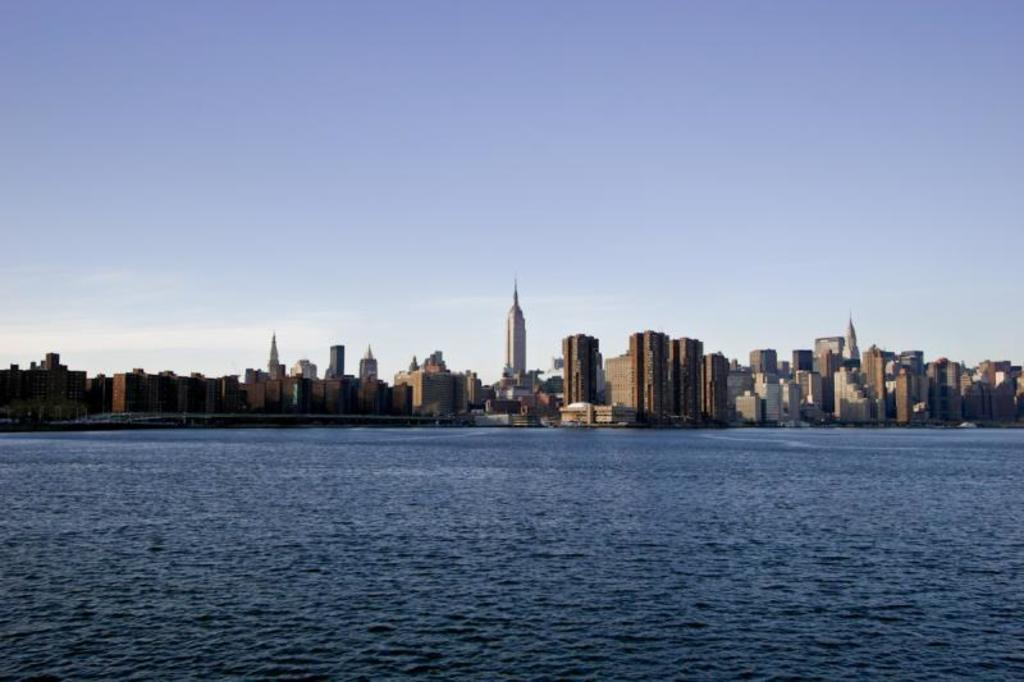What type of natural feature can be seen in the image? There is a river in the image. What part of an object or structure is visible in the image? The back side of something is visible in the image. What type of man-made structures are present in the image? There are multiple buildings in the image. Can you see a beggar asking for money near the river in the image? There is no beggar present in the image. What type of plant is growing near the buildings in the image? The provided facts do not mention any plants, including cacti, in the image. 